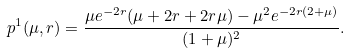<formula> <loc_0><loc_0><loc_500><loc_500>p ^ { 1 } ( \mu , r ) = \frac { \mu e ^ { - 2 r } ( \mu + 2 r + 2 r \mu ) - \mu ^ { 2 } e ^ { - 2 r ( 2 + \mu ) } } { ( 1 + \mu ) ^ { 2 } } .</formula> 